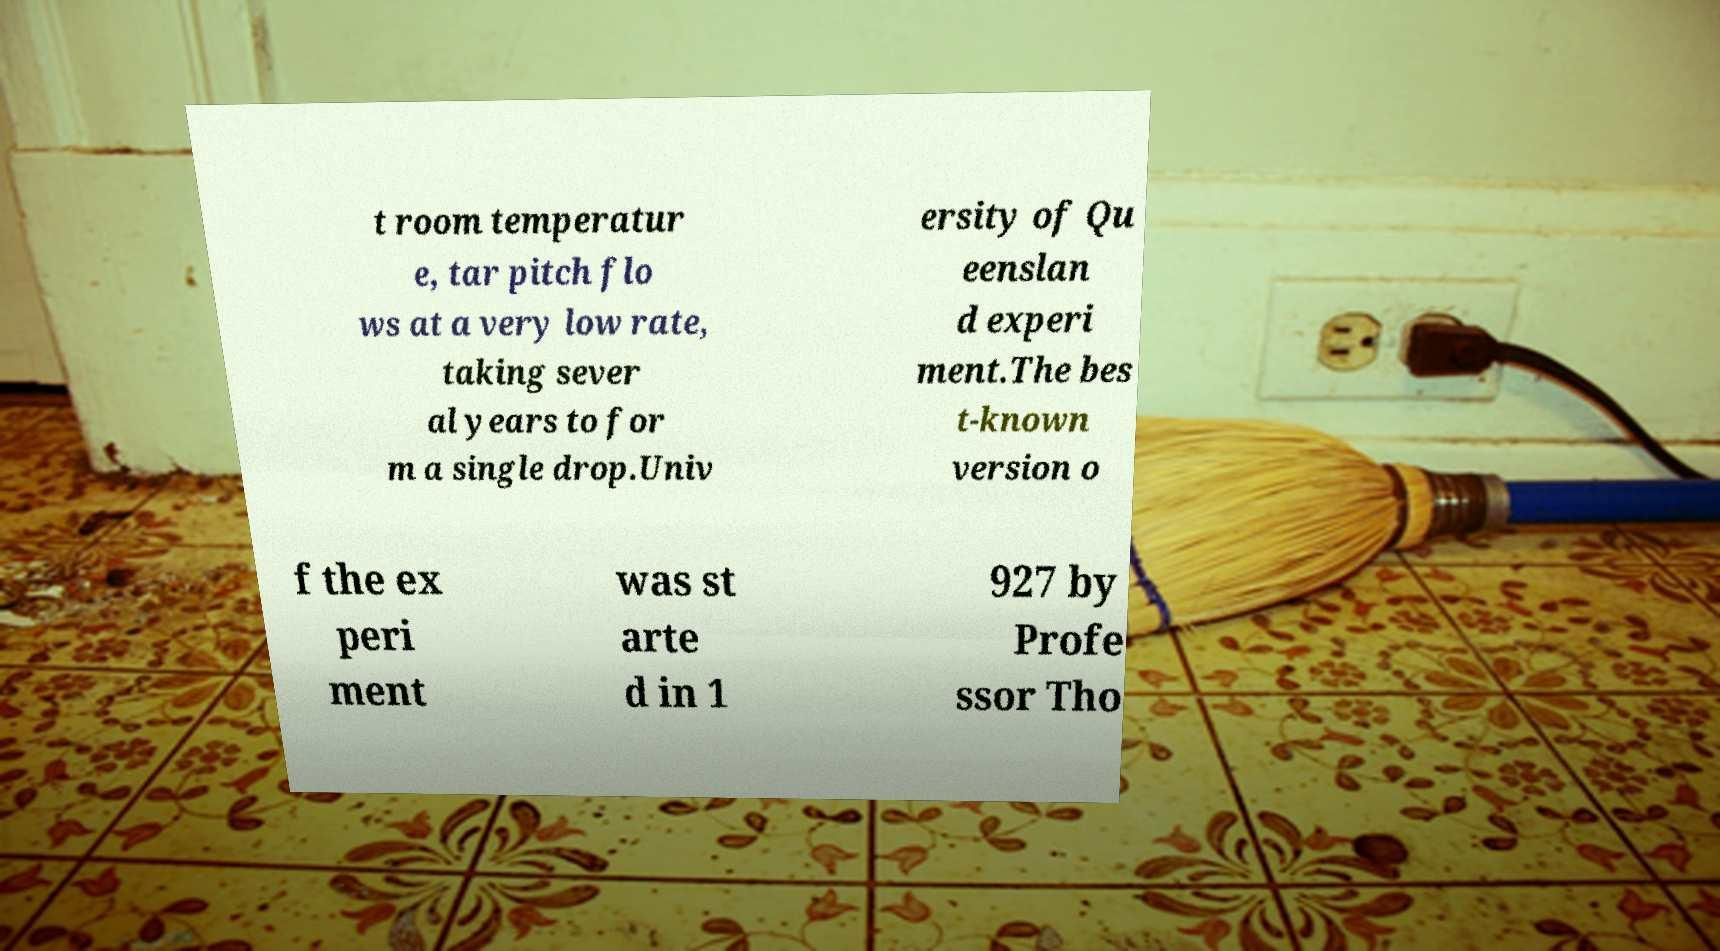There's text embedded in this image that I need extracted. Can you transcribe it verbatim? t room temperatur e, tar pitch flo ws at a very low rate, taking sever al years to for m a single drop.Univ ersity of Qu eenslan d experi ment.The bes t-known version o f the ex peri ment was st arte d in 1 927 by Profe ssor Tho 